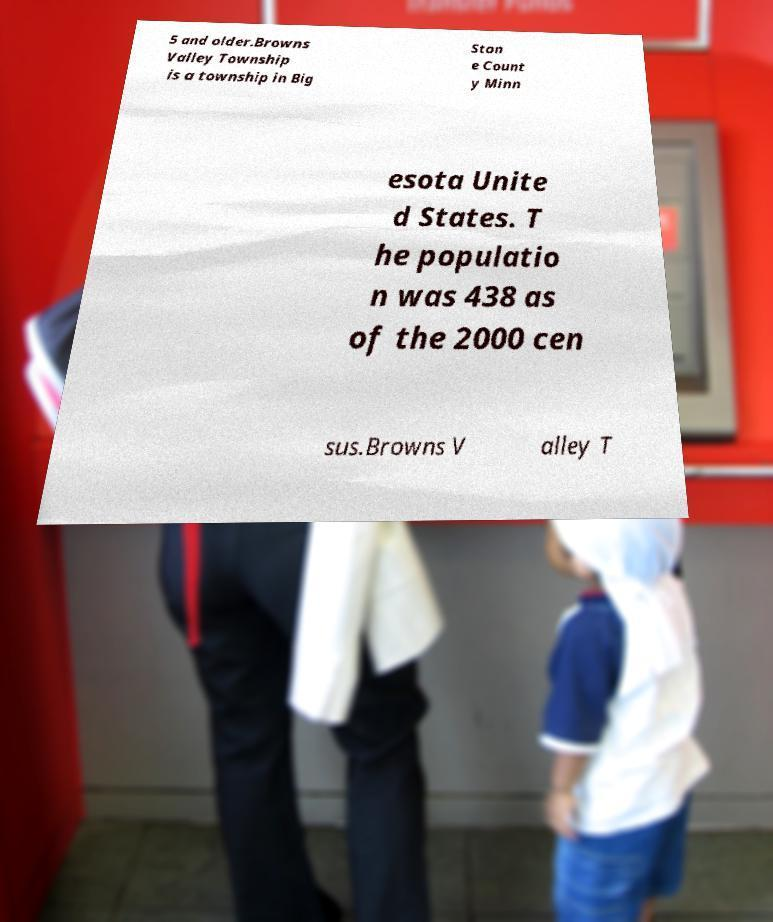Can you read and provide the text displayed in the image?This photo seems to have some interesting text. Can you extract and type it out for me? 5 and older.Browns Valley Township is a township in Big Ston e Count y Minn esota Unite d States. T he populatio n was 438 as of the 2000 cen sus.Browns V alley T 